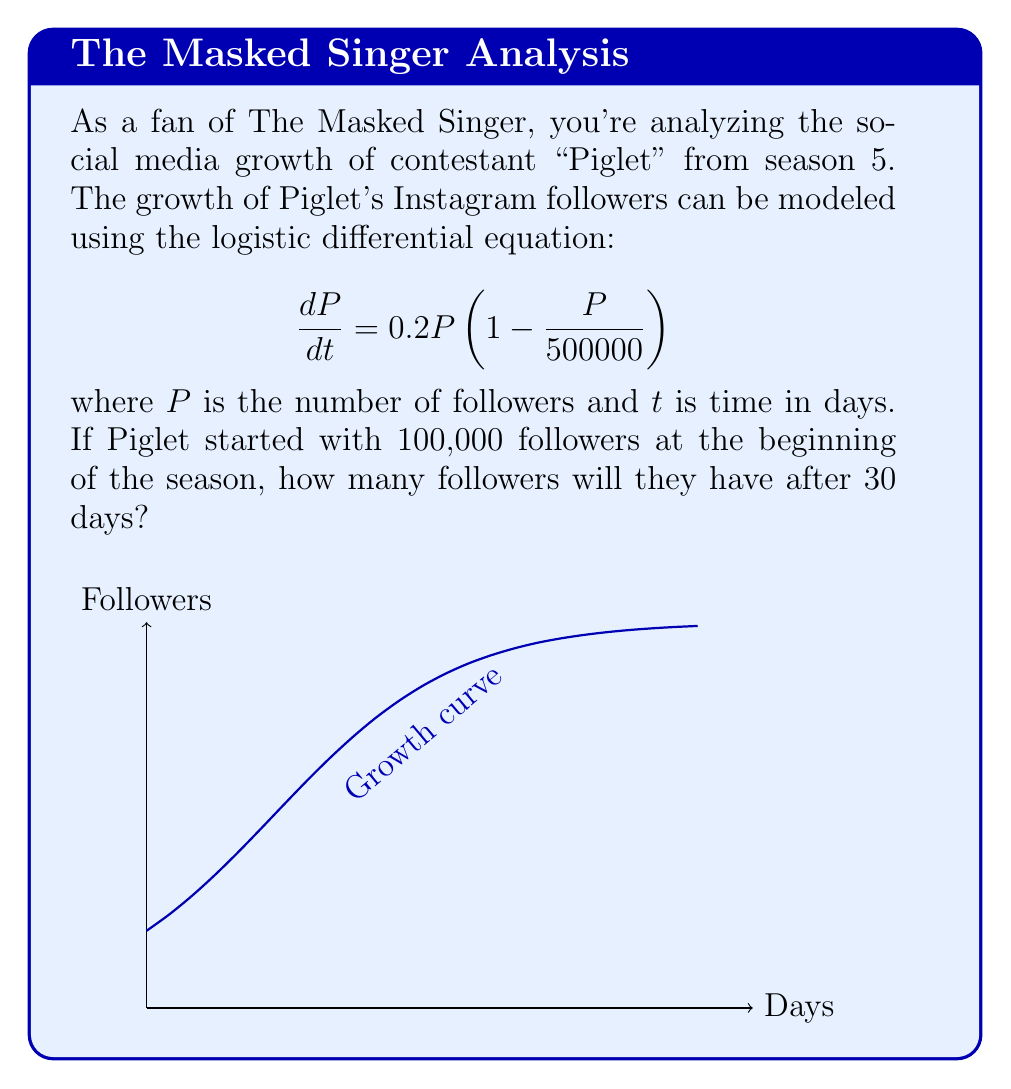Give your solution to this math problem. To solve this logistic differential equation, we follow these steps:

1) The general solution to the logistic equation $\frac{dP}{dt} = rP(1 - \frac{P}{K})$ is:

   $$P(t) = \frac{K}{1 + (\frac{K}{P_0} - 1)e^{-rt}}$$

   where $K$ is the carrying capacity, $r$ is the growth rate, and $P_0$ is the initial population.

2) In our case, $K = 500000$, $r = 0.2$, and $P_0 = 100000$.

3) Substituting these values into the general solution:

   $$P(t) = \frac{500000}{1 + (\frac{500000}{100000} - 1)e^{-0.2t}}$$

4) Simplify:
   
   $$P(t) = \frac{500000}{1 + 4e^{-0.2t}}$$

5) Now, we want to find $P(30)$, so we substitute $t = 30$:

   $$P(30) = \frac{500000}{1 + 4e^{-0.2(30)}}$$

6) Calculate:
   
   $$P(30) = \frac{500000}{1 + 4e^{-6}} \approx 418,156$$

Therefore, after 30 days, Piglet will have approximately 418,156 followers.
Answer: 418,156 followers 